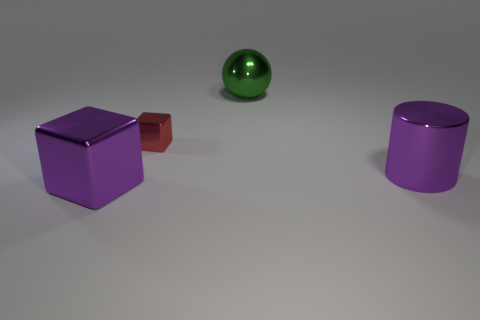How does the color of the objects contribute to the composition of the image? The image employs a minimalist color palette with purposeful placement of objects to create a cohesive composition. The repetition of the purple hue across the cube and the cylinder forms a visual link between these elements, thereby uniting the scene. The contrast provided by the brown cube adds depth and draws attention due to its difference in tone and size. Meanwhile, the green sphere injects a pop of complementary color, which further balances the composition and invites the eye to move around the image. The careful use of color aids in generating visual interest within a simplistic setup. 